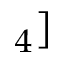Convert formula to latex. <formula><loc_0><loc_0><loc_500><loc_500>_ { 4 } ]</formula> 